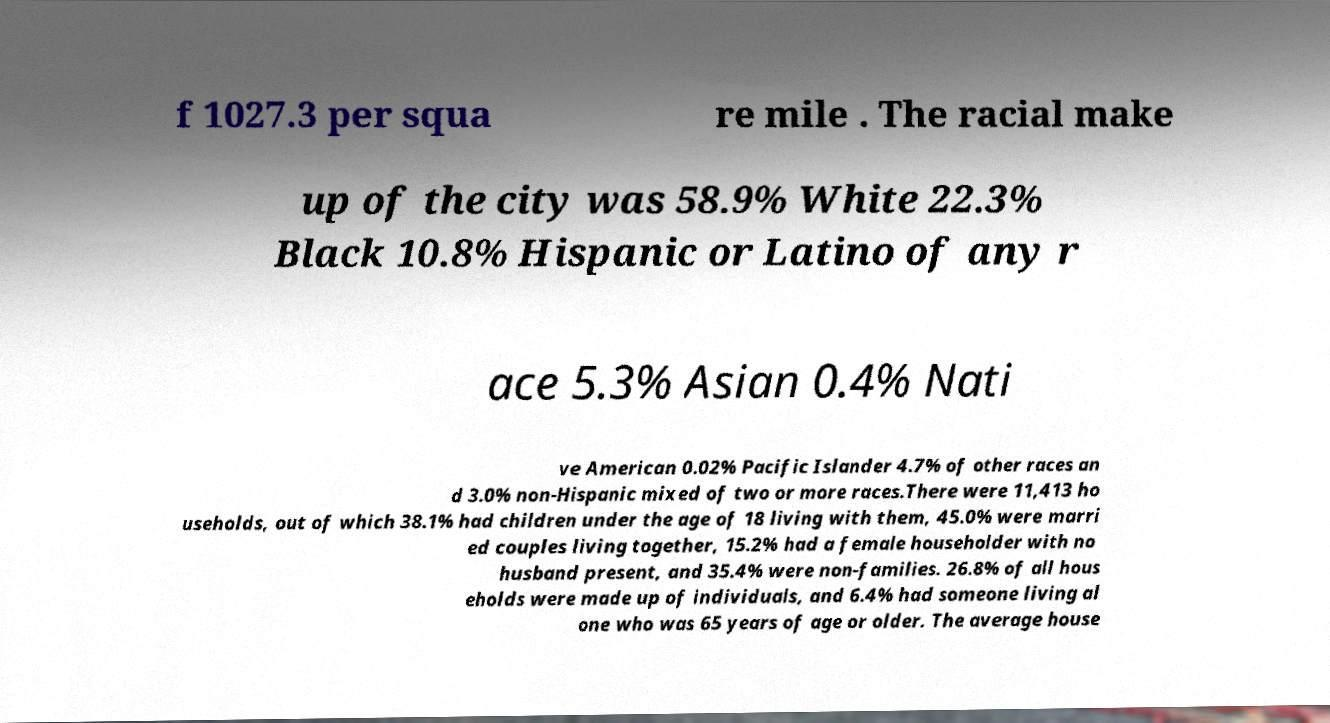Please identify and transcribe the text found in this image. f 1027.3 per squa re mile . The racial make up of the city was 58.9% White 22.3% Black 10.8% Hispanic or Latino of any r ace 5.3% Asian 0.4% Nati ve American 0.02% Pacific Islander 4.7% of other races an d 3.0% non-Hispanic mixed of two or more races.There were 11,413 ho useholds, out of which 38.1% had children under the age of 18 living with them, 45.0% were marri ed couples living together, 15.2% had a female householder with no husband present, and 35.4% were non-families. 26.8% of all hous eholds were made up of individuals, and 6.4% had someone living al one who was 65 years of age or older. The average house 